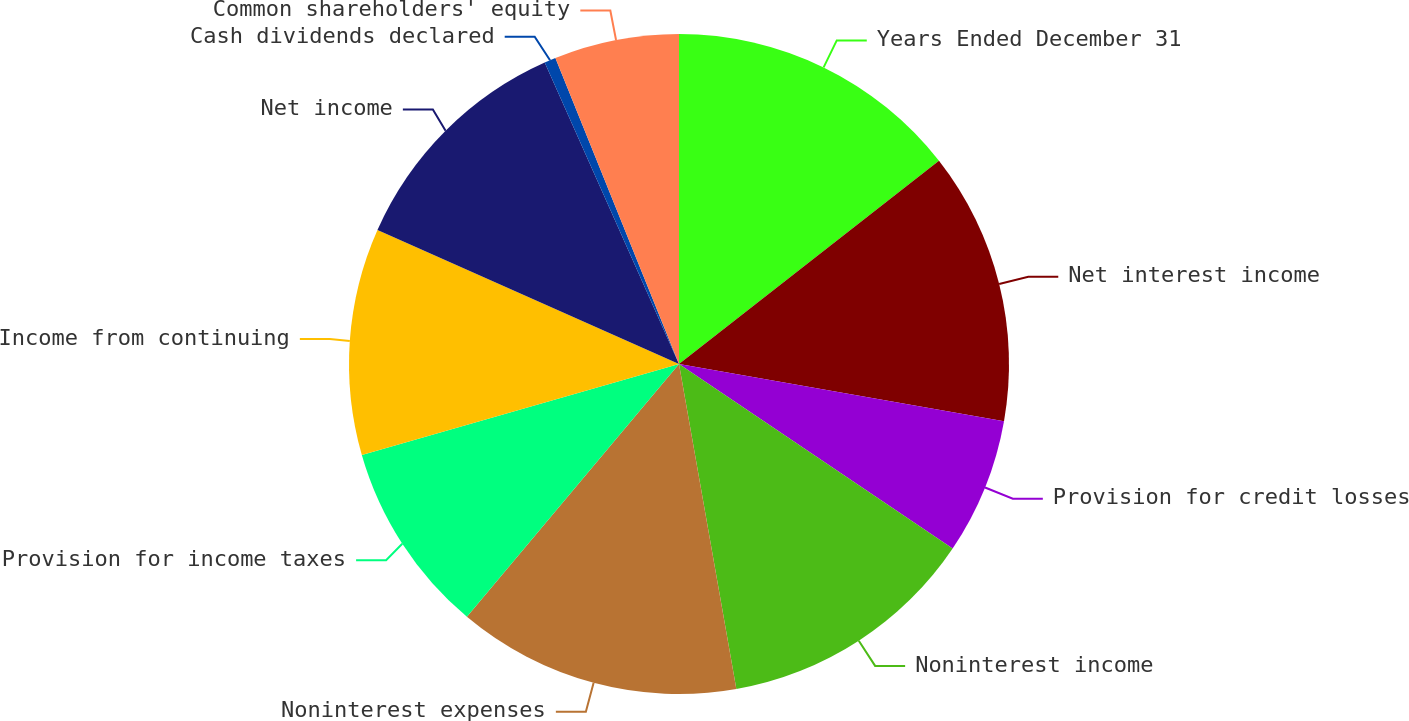<chart> <loc_0><loc_0><loc_500><loc_500><pie_chart><fcel>Years Ended December 31<fcel>Net interest income<fcel>Provision for credit losses<fcel>Noninterest income<fcel>Noninterest expenses<fcel>Provision for income taxes<fcel>Income from continuing<fcel>Net income<fcel>Cash dividends declared<fcel>Common shareholders' equity<nl><fcel>14.44%<fcel>13.33%<fcel>6.67%<fcel>12.78%<fcel>13.89%<fcel>9.44%<fcel>11.11%<fcel>11.67%<fcel>0.56%<fcel>6.11%<nl></chart> 